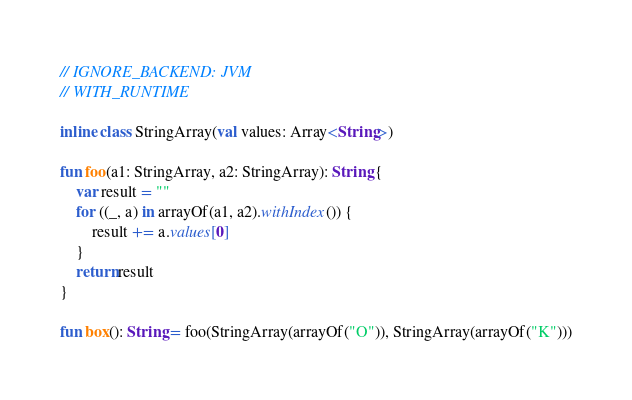Convert code to text. <code><loc_0><loc_0><loc_500><loc_500><_Kotlin_>// IGNORE_BACKEND: JVM
// WITH_RUNTIME

inline class StringArray(val values: Array<String>)

fun foo(a1: StringArray, a2: StringArray): String {
    var result = ""
    for ((_, a) in arrayOf(a1, a2).withIndex()) {
        result += a.values[0]
    }
    return result
}

fun box(): String = foo(StringArray(arrayOf("O")), StringArray(arrayOf("K")))
</code> 